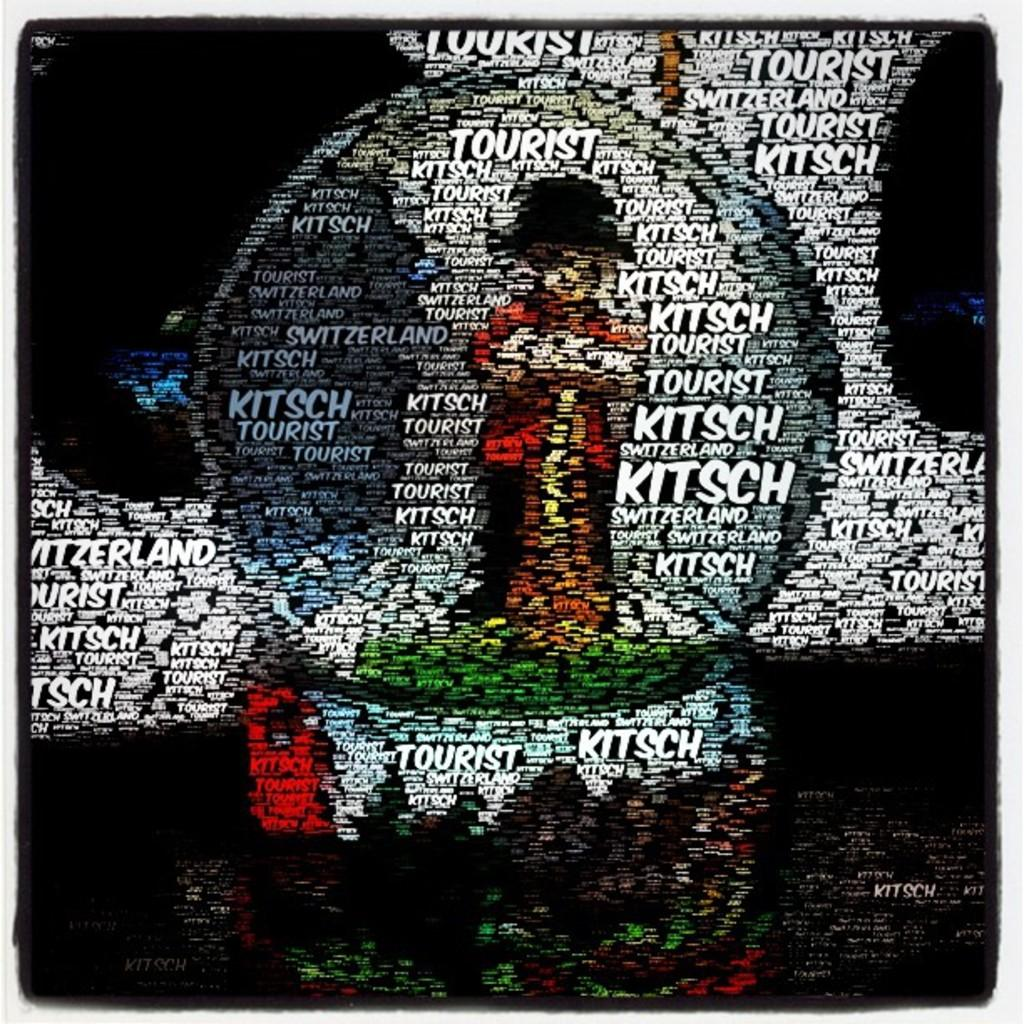<image>
Give a short and clear explanation of the subsequent image. A snowglobe and background completely made of the words Kitsch in different sizes and colors. 